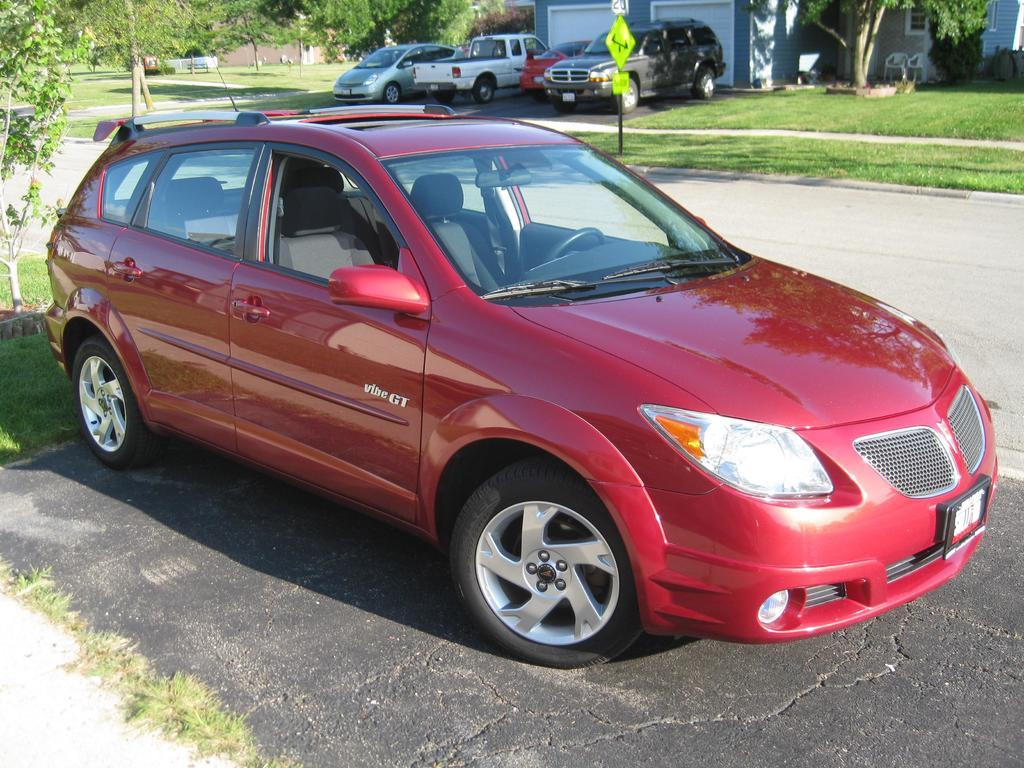What is the main subject of the image? There is a car in the image. What type of vegetation can be seen in the image? There is grass and a plant visible in the image. What structure can be seen in the background of the image? There is a house in the background of the image. What else can be seen in the background of the image? There are trees and vehicles in the background of the image. What type of surface is visible in the image? There is a road in the image. What is attached to the pole in the image? There are boards on a pole in the image. Is there a river flowing through the image? No, there is no river present in the image. What time of day is it in the image, based on the hour? The image does not provide information about the time of day or the hour. 